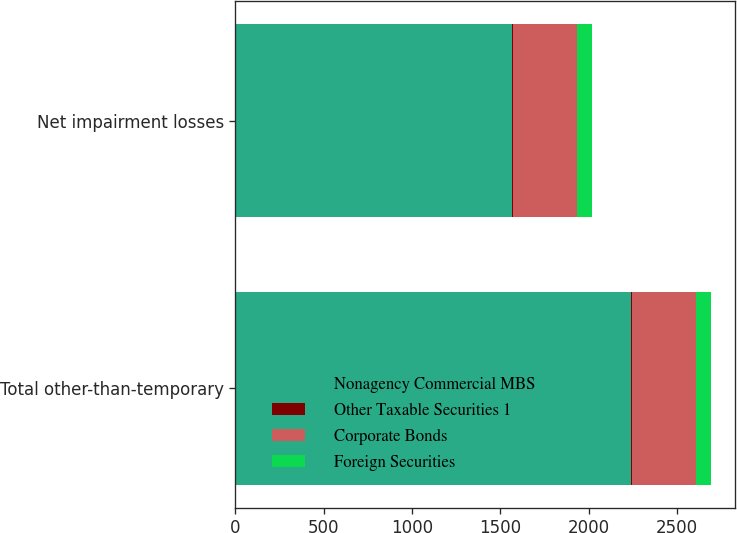<chart> <loc_0><loc_0><loc_500><loc_500><stacked_bar_chart><ecel><fcel>Total other-than-temporary<fcel>Net impairment losses<nl><fcel>Nonagency Commercial MBS<fcel>2240<fcel>1568<nl><fcel>Other Taxable Securities 1<fcel>6<fcel>6<nl><fcel>Corporate Bonds<fcel>360<fcel>360<nl><fcel>Foreign Securities<fcel>87<fcel>87<nl></chart> 